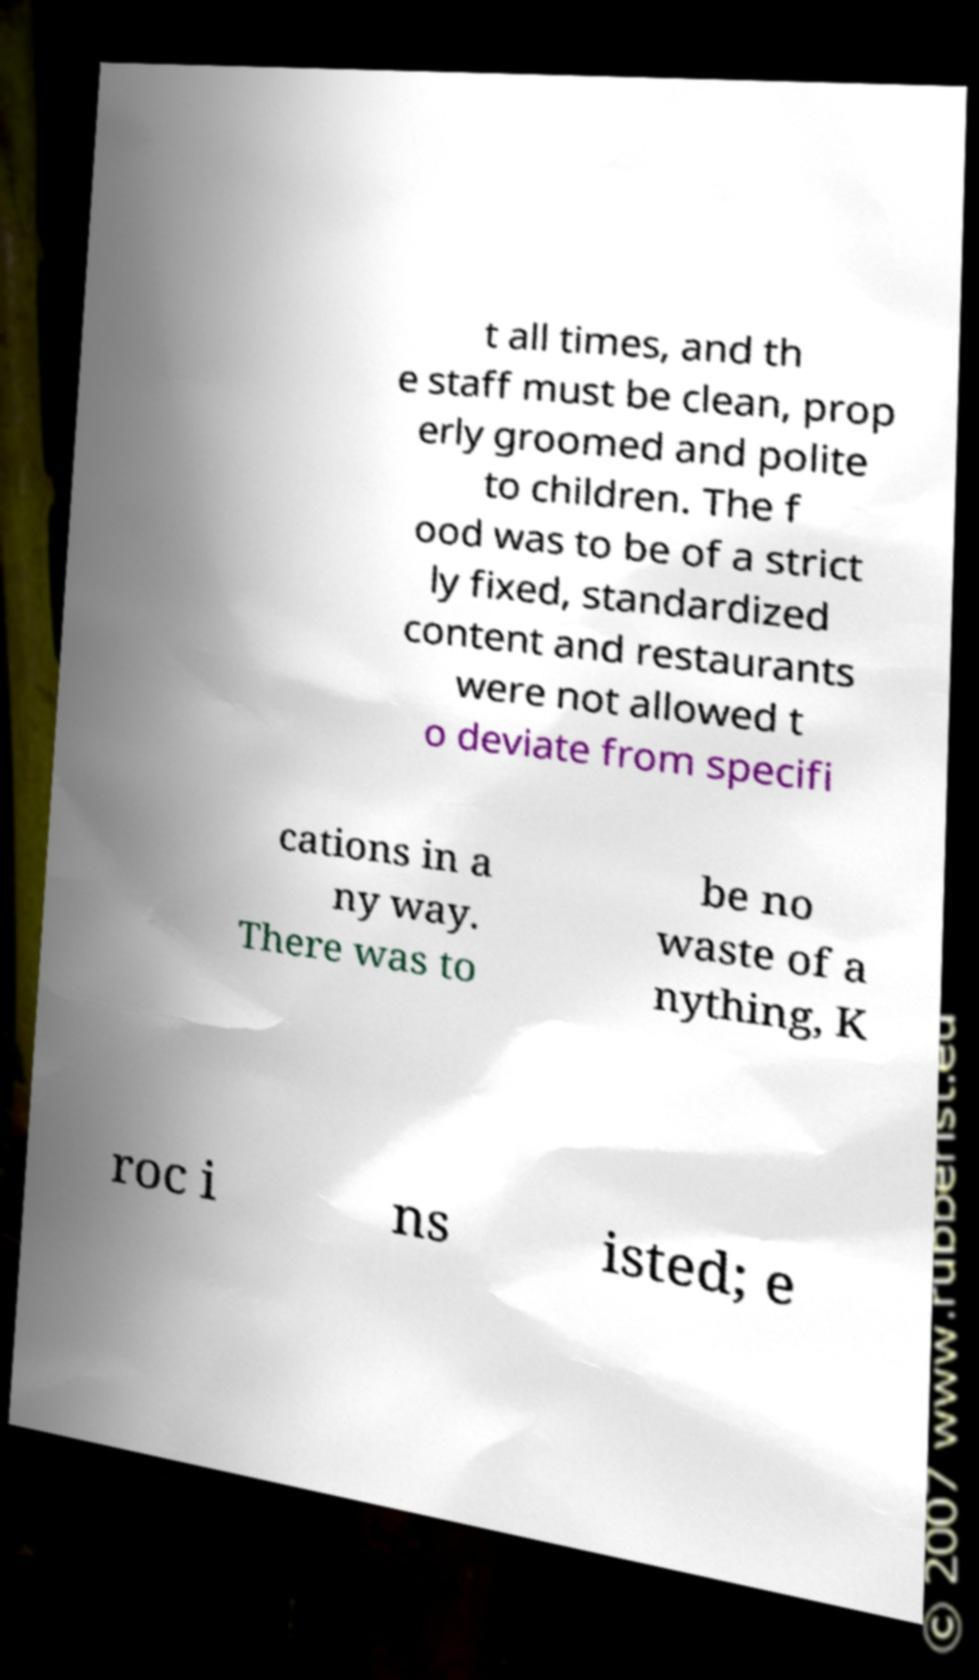I need the written content from this picture converted into text. Can you do that? t all times, and th e staff must be clean, prop erly groomed and polite to children. The f ood was to be of a strict ly fixed, standardized content and restaurants were not allowed t o deviate from specifi cations in a ny way. There was to be no waste of a nything, K roc i ns isted; e 